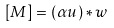Convert formula to latex. <formula><loc_0><loc_0><loc_500><loc_500>[ M ] = ( \alpha u ) * w</formula> 